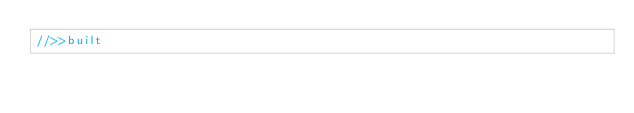<code> <loc_0><loc_0><loc_500><loc_500><_JavaScript_>//>>built</code> 